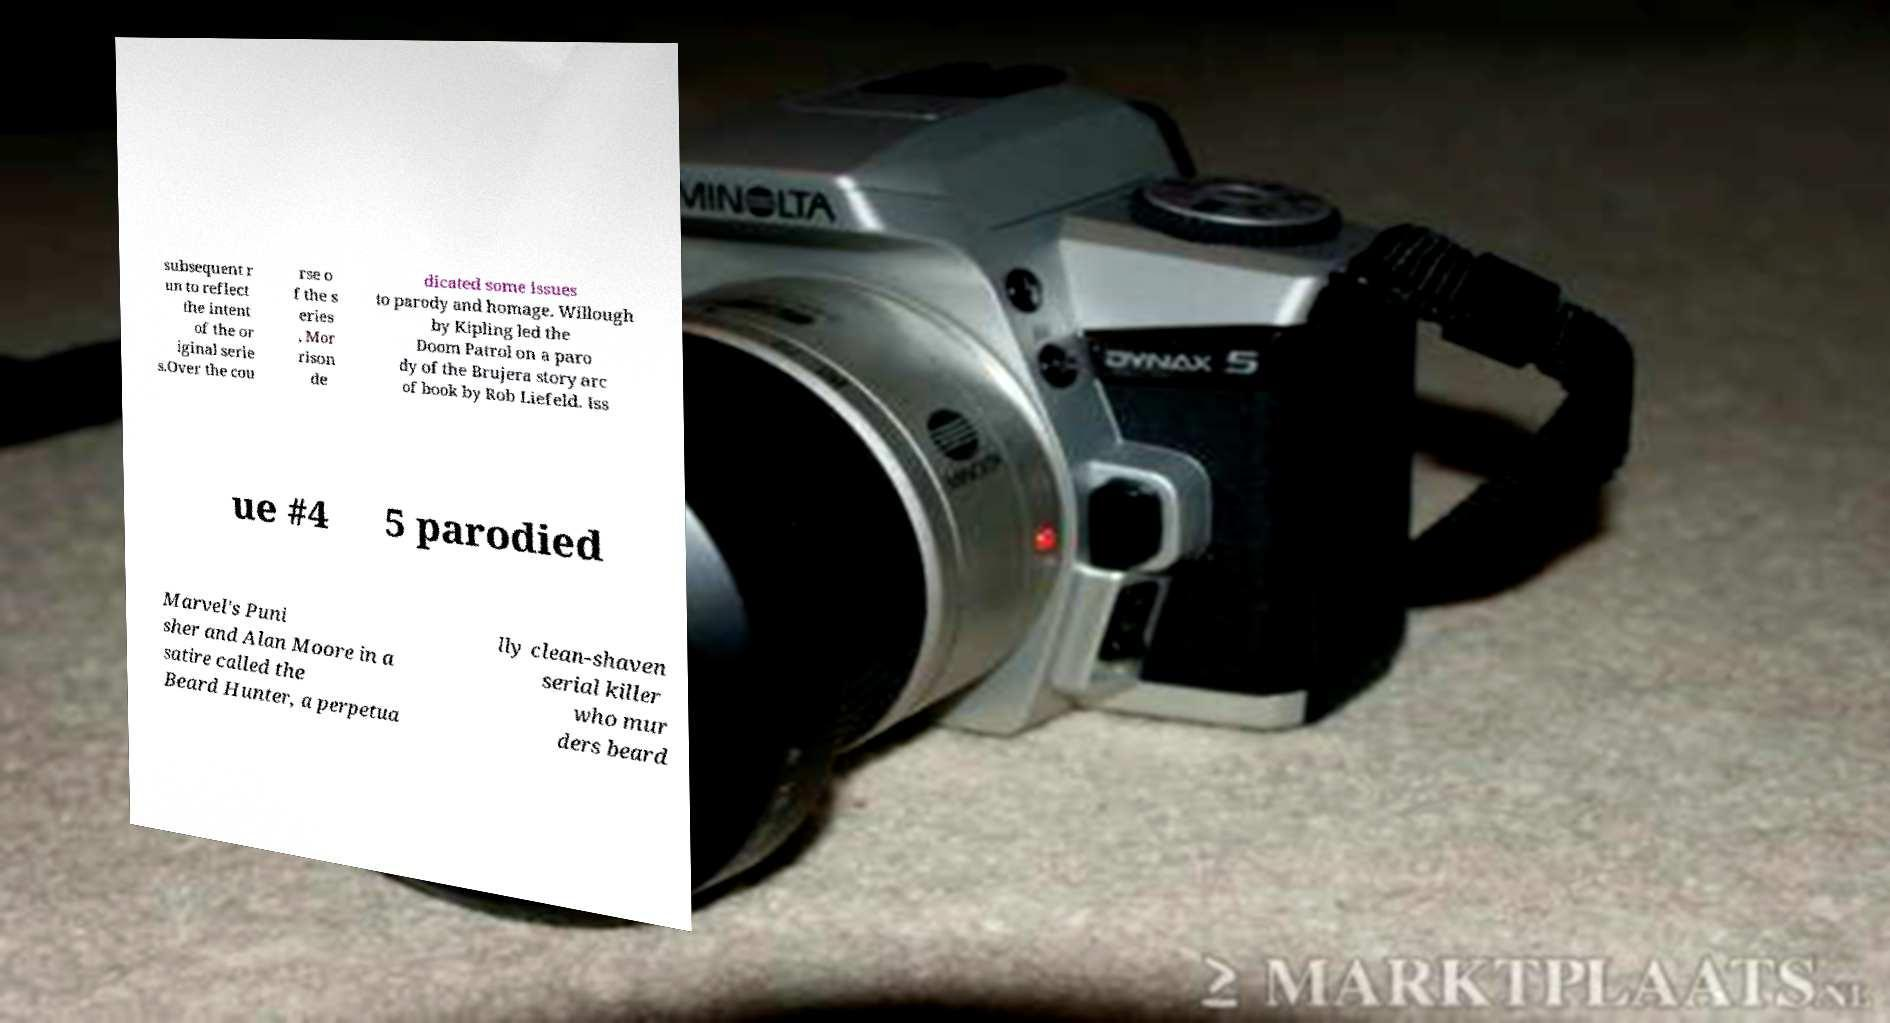I need the written content from this picture converted into text. Can you do that? subsequent r un to reflect the intent of the or iginal serie s.Over the cou rse o f the s eries , Mor rison de dicated some issues to parody and homage. Willough by Kipling led the Doom Patrol on a paro dy of the Brujera story arc of book by Rob Liefeld. Iss ue #4 5 parodied Marvel's Puni sher and Alan Moore in a satire called the Beard Hunter, a perpetua lly clean-shaven serial killer who mur ders beard 